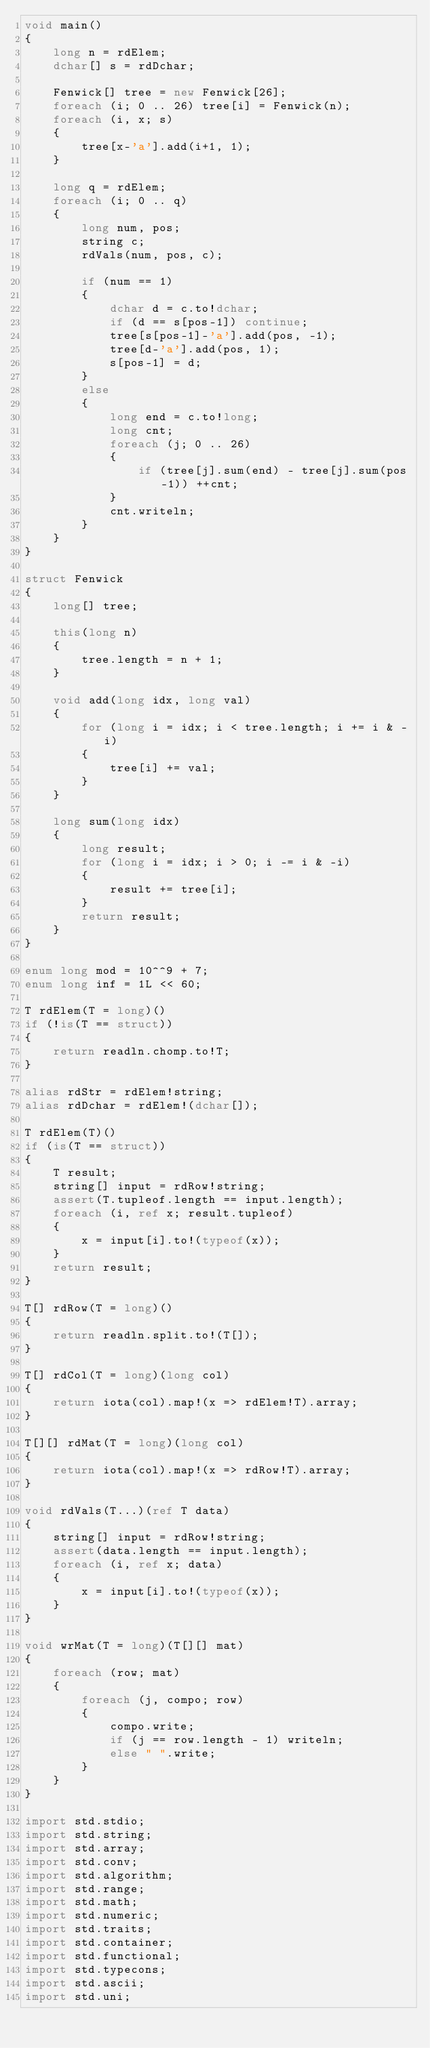<code> <loc_0><loc_0><loc_500><loc_500><_D_>void main()
{
    long n = rdElem;
    dchar[] s = rdDchar;

    Fenwick[] tree = new Fenwick[26];
    foreach (i; 0 .. 26) tree[i] = Fenwick(n);
    foreach (i, x; s)
    {
        tree[x-'a'].add(i+1, 1);
    }

    long q = rdElem;
    foreach (i; 0 .. q)
    {
        long num, pos;
        string c;
        rdVals(num, pos, c);

        if (num == 1)
        {
            dchar d = c.to!dchar;
            if (d == s[pos-1]) continue;
            tree[s[pos-1]-'a'].add(pos, -1);
            tree[d-'a'].add(pos, 1);
            s[pos-1] = d;
        }
        else
        {
            long end = c.to!long;
            long cnt;
            foreach (j; 0 .. 26)
            {
                if (tree[j].sum(end) - tree[j].sum(pos-1)) ++cnt;
            }
            cnt.writeln;
        }
    }
}

struct Fenwick
{
    long[] tree;

    this(long n)
    {
        tree.length = n + 1;
    }

    void add(long idx, long val)
    {
        for (long i = idx; i < tree.length; i += i & -i)
        {
            tree[i] += val;
        }
    }

    long sum(long idx)
    {
        long result;
        for (long i = idx; i > 0; i -= i & -i)
        {
            result += tree[i];
        }
        return result;
    }
}

enum long mod = 10^^9 + 7;
enum long inf = 1L << 60;

T rdElem(T = long)()
if (!is(T == struct))
{
    return readln.chomp.to!T;
}

alias rdStr = rdElem!string;
alias rdDchar = rdElem!(dchar[]);

T rdElem(T)()
if (is(T == struct))
{
    T result;
    string[] input = rdRow!string;
    assert(T.tupleof.length == input.length);
    foreach (i, ref x; result.tupleof)
    {
        x = input[i].to!(typeof(x));
    }
    return result;
}

T[] rdRow(T = long)()
{
    return readln.split.to!(T[]);
}

T[] rdCol(T = long)(long col)
{
    return iota(col).map!(x => rdElem!T).array;
}

T[][] rdMat(T = long)(long col)
{
    return iota(col).map!(x => rdRow!T).array;
}

void rdVals(T...)(ref T data)
{
    string[] input = rdRow!string;
    assert(data.length == input.length);
    foreach (i, ref x; data)
    {
        x = input[i].to!(typeof(x));
    }
}

void wrMat(T = long)(T[][] mat)
{
    foreach (row; mat)
    {
        foreach (j, compo; row)
        {
            compo.write;
            if (j == row.length - 1) writeln;
            else " ".write;
        }
    }
}

import std.stdio;
import std.string;
import std.array;
import std.conv;
import std.algorithm;
import std.range;
import std.math;
import std.numeric;
import std.traits;
import std.container;
import std.functional;
import std.typecons;
import std.ascii;
import std.uni;</code> 